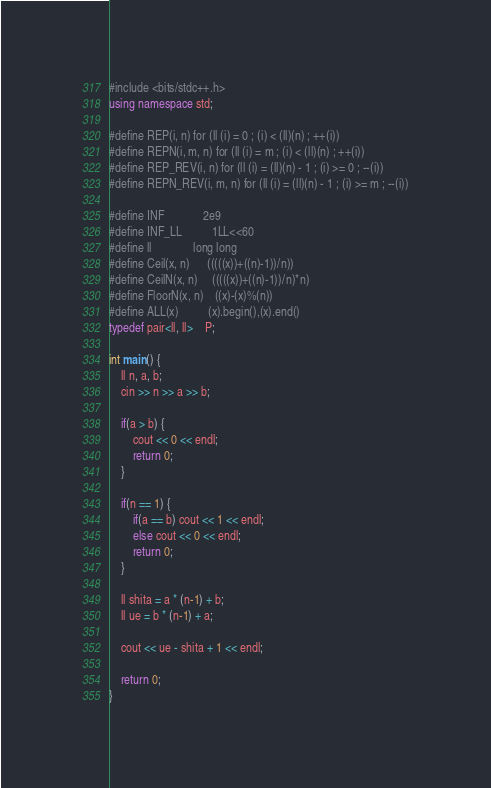Convert code to text. <code><loc_0><loc_0><loc_500><loc_500><_C++_>
#include <bits/stdc++.h>
using namespace std;

#define REP(i, n) for (ll (i) = 0 ; (i) < (ll)(n) ; ++(i))
#define REPN(i, m, n) for (ll (i) = m ; (i) < (ll)(n) ; ++(i))
#define REP_REV(i, n) for (ll (i) = (ll)(n) - 1 ; (i) >= 0 ; --(i))
#define REPN_REV(i, m, n) for (ll (i) = (ll)(n) - 1 ; (i) >= m ; --(i))

#define INF             2e9
#define INF_LL          1LL<<60
#define ll              long long
#define Ceil(x, n)      (((((x))+((n)-1))/n))
#define CeilN(x, n)     (((((x))+((n)-1))/n)*n)
#define FloorN(x, n)    ((x)-(x)%(n))
#define ALL(x)          (x).begin(),(x).end()
typedef pair<ll, ll>    P;

int main() {
    ll n, a, b;
    cin >> n >> a >> b;

    if(a > b) {
        cout << 0 << endl;
        return 0;
    }

    if(n == 1) {
        if(a == b) cout << 1 << endl;
        else cout << 0 << endl;
        return 0;
    }

    ll shita = a * (n-1) + b;
    ll ue = b * (n-1) + a;

    cout << ue - shita + 1 << endl;

    return 0;
}</code> 